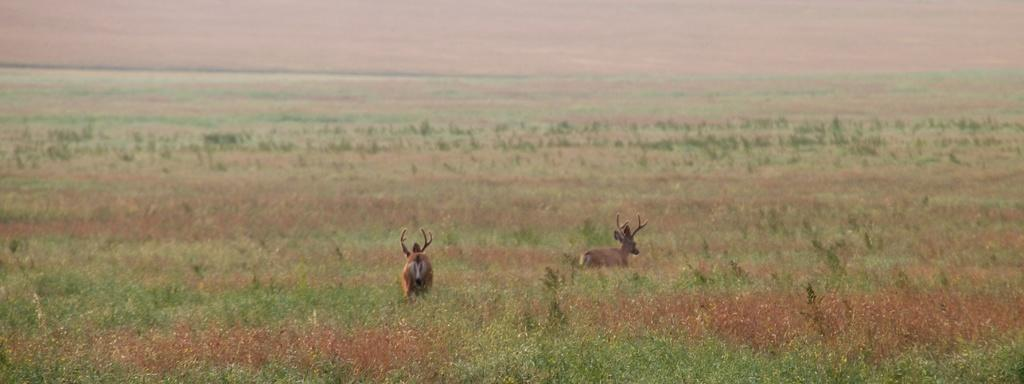What type of animal is in the image? There is a deer in the image. What else can be seen in the image besides the deer? There are plants in the image. Can you describe the background of the image? The background of the image is blurry. What type of horn is on the chair in the image? There is no chair or horn present in the image; it features a deer and plants. 